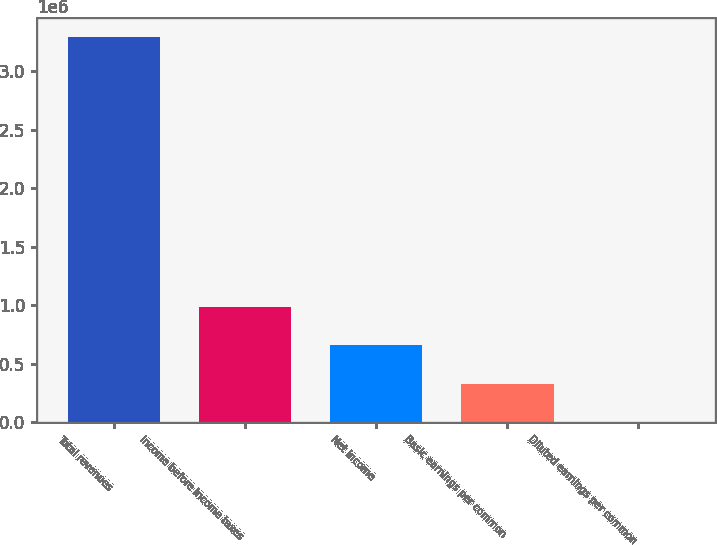Convert chart. <chart><loc_0><loc_0><loc_500><loc_500><bar_chart><fcel>Total revenues<fcel>Income before income taxes<fcel>Net income<fcel>Basic earnings per common<fcel>Diluted earnings per common<nl><fcel>3.28695e+06<fcel>986085<fcel>657390<fcel>328695<fcel>0.41<nl></chart> 